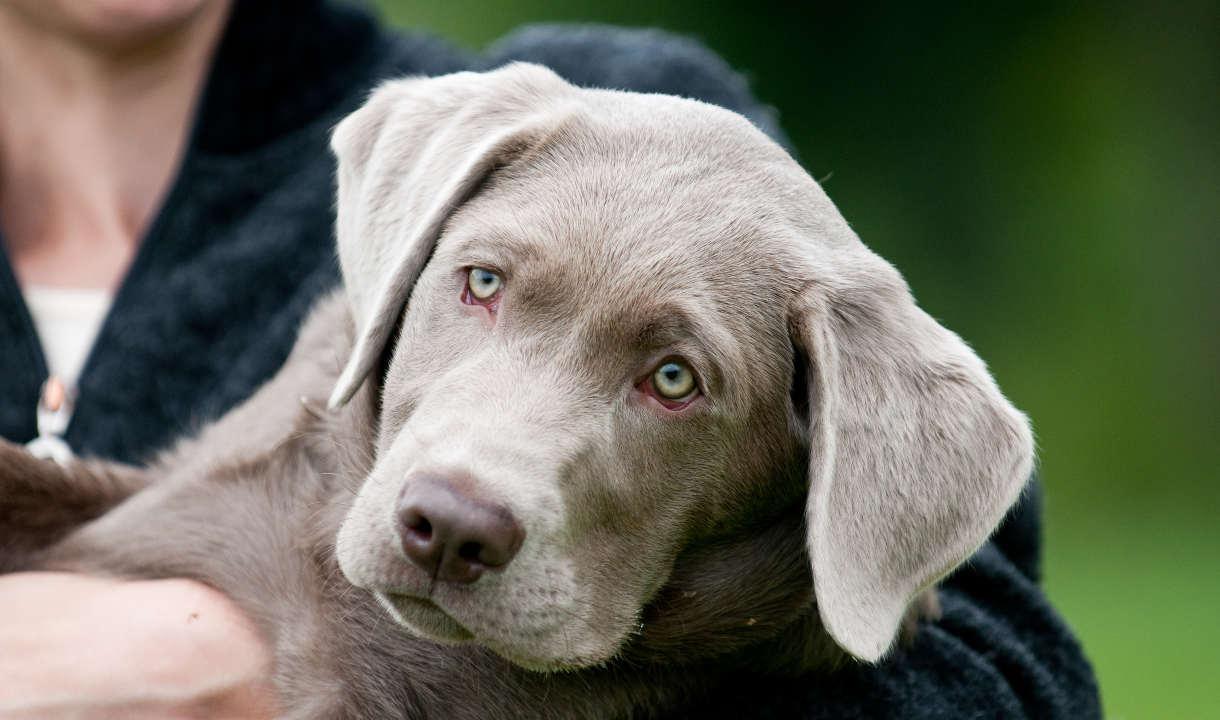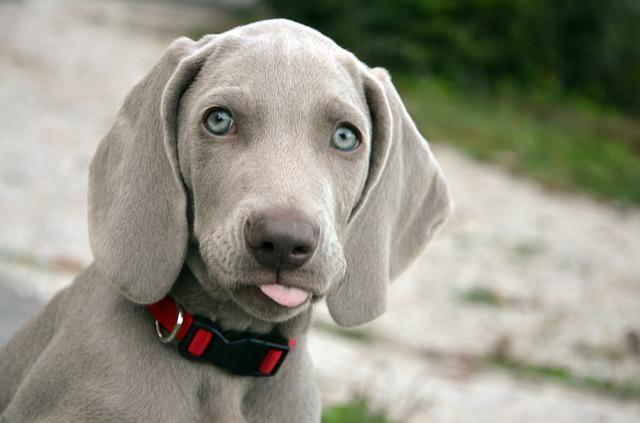The first image is the image on the left, the second image is the image on the right. Analyze the images presented: Is the assertion "Someone is holding one of the dogs." valid? Answer yes or no. Yes. The first image is the image on the left, the second image is the image on the right. Given the left and right images, does the statement "An image shows a blue-eyed gray dog wearing a red collar." hold true? Answer yes or no. Yes. 